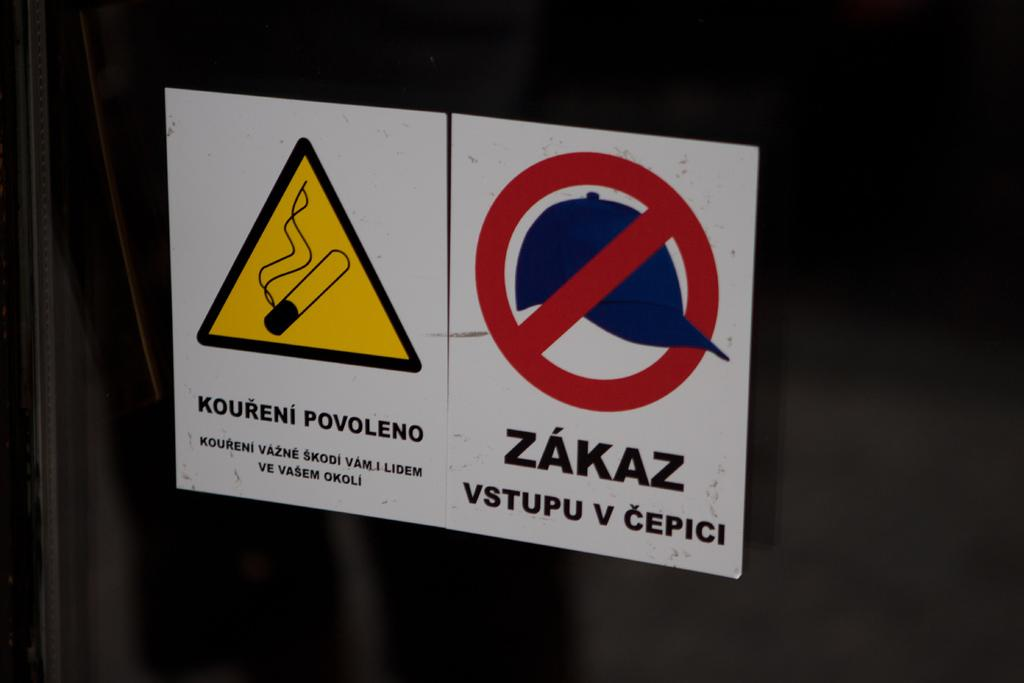<image>
Write a terse but informative summary of the picture. A sign has a hat with a line through it and the word zakaz. 